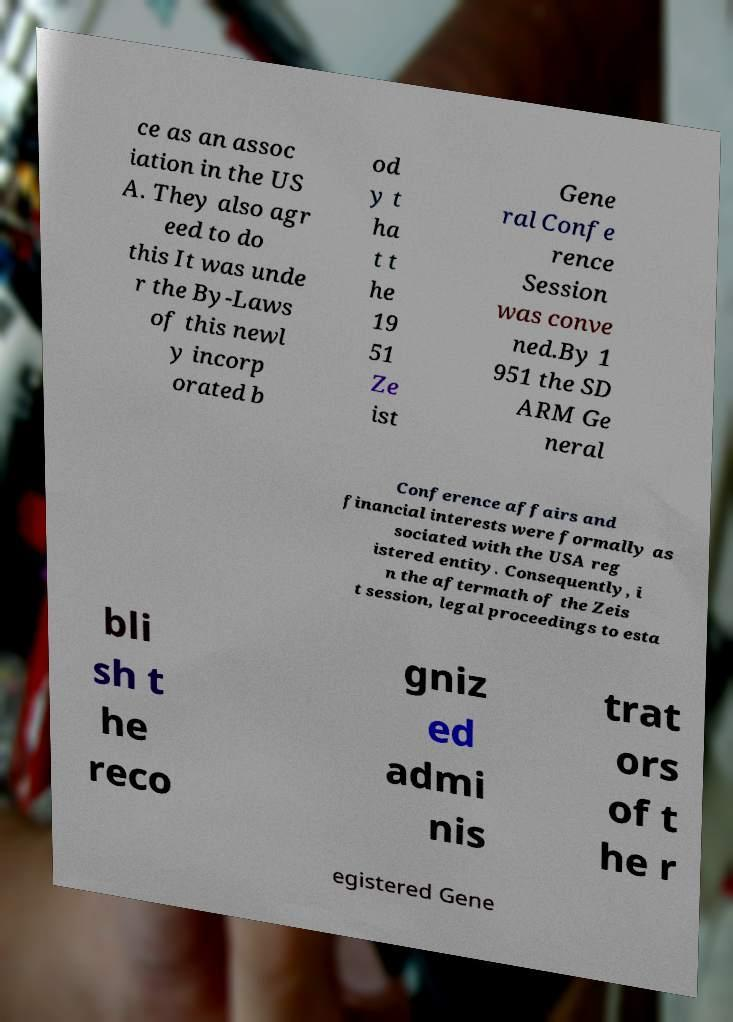Can you accurately transcribe the text from the provided image for me? ce as an assoc iation in the US A. They also agr eed to do this It was unde r the By-Laws of this newl y incorp orated b od y t ha t t he 19 51 Ze ist Gene ral Confe rence Session was conve ned.By 1 951 the SD ARM Ge neral Conference affairs and financial interests were formally as sociated with the USA reg istered entity. Consequently, i n the aftermath of the Zeis t session, legal proceedings to esta bli sh t he reco gniz ed admi nis trat ors of t he r egistered Gene 